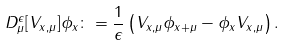Convert formula to latex. <formula><loc_0><loc_0><loc_500><loc_500>D _ { \mu } ^ { \epsilon } [ V _ { x , \mu } ] \phi _ { x } \colon = \frac { 1 } { \epsilon } \left ( V _ { x , \mu } \phi _ { x + \mu } - \phi _ { x } V _ { x , \mu } \right ) .</formula> 